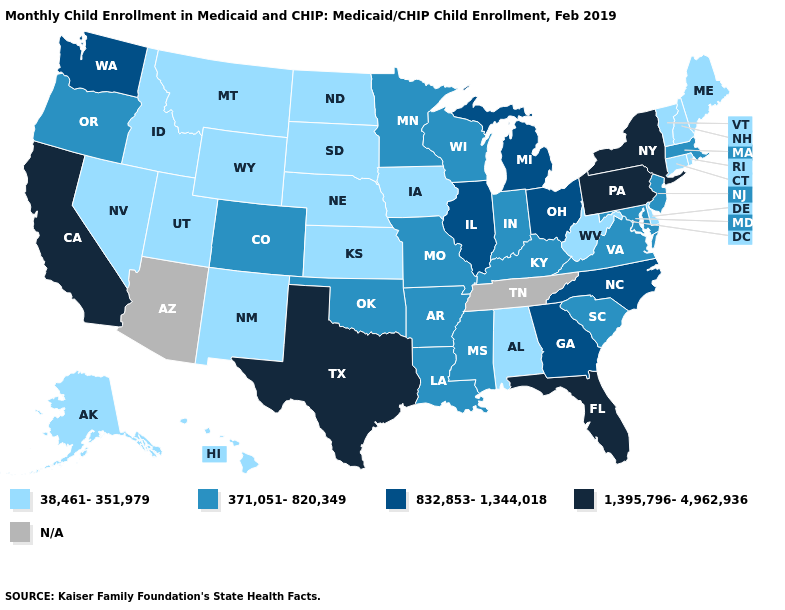What is the value of South Carolina?
Concise answer only. 371,051-820,349. What is the highest value in the USA?
Short answer required. 1,395,796-4,962,936. Among the states that border Vermont , does Massachusetts have the highest value?
Concise answer only. No. Among the states that border Washington , does Oregon have the lowest value?
Keep it brief. No. Among the states that border Louisiana , which have the lowest value?
Short answer required. Arkansas, Mississippi. What is the value of Wyoming?
Keep it brief. 38,461-351,979. What is the value of Georgia?
Be succinct. 832,853-1,344,018. What is the highest value in states that border Maine?
Be succinct. 38,461-351,979. Name the states that have a value in the range N/A?
Be succinct. Arizona, Tennessee. Name the states that have a value in the range 371,051-820,349?
Answer briefly. Arkansas, Colorado, Indiana, Kentucky, Louisiana, Maryland, Massachusetts, Minnesota, Mississippi, Missouri, New Jersey, Oklahoma, Oregon, South Carolina, Virginia, Wisconsin. Name the states that have a value in the range 38,461-351,979?
Keep it brief. Alabama, Alaska, Connecticut, Delaware, Hawaii, Idaho, Iowa, Kansas, Maine, Montana, Nebraska, Nevada, New Hampshire, New Mexico, North Dakota, Rhode Island, South Dakota, Utah, Vermont, West Virginia, Wyoming. Does Texas have the lowest value in the USA?
Write a very short answer. No. Among the states that border Oregon , which have the lowest value?
Answer briefly. Idaho, Nevada. 